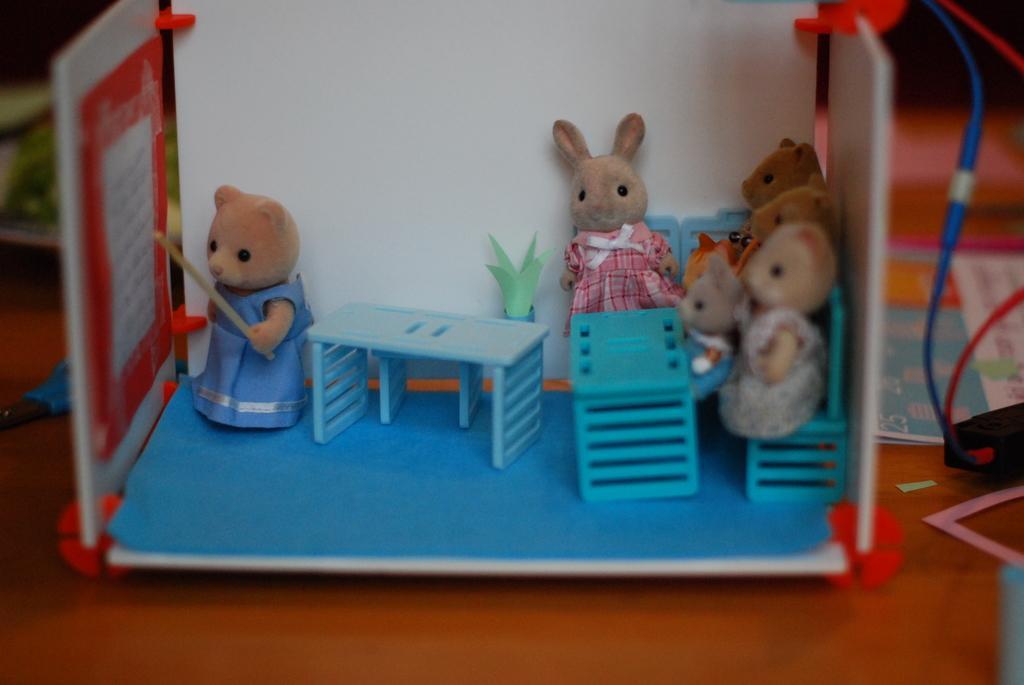Can you describe this image briefly? To the bottom of the image there is a wooden surface. On the surface there is a box of toys in it. To the right of the box there are few toys sitting on the blue chairs, In front of them there are blue tables and also there is a pot. To the left corner of the image there is another toy with dress is standing and holding the stick in his hand. To the right corner of the image there are wires to the black box. 